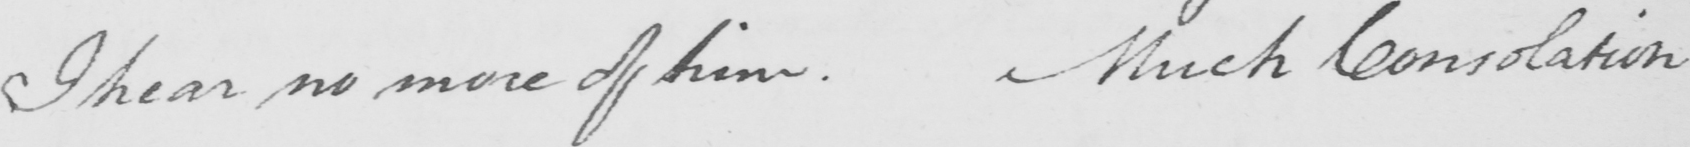Can you tell me what this handwritten text says? I hear no more of him . Much Consolation 